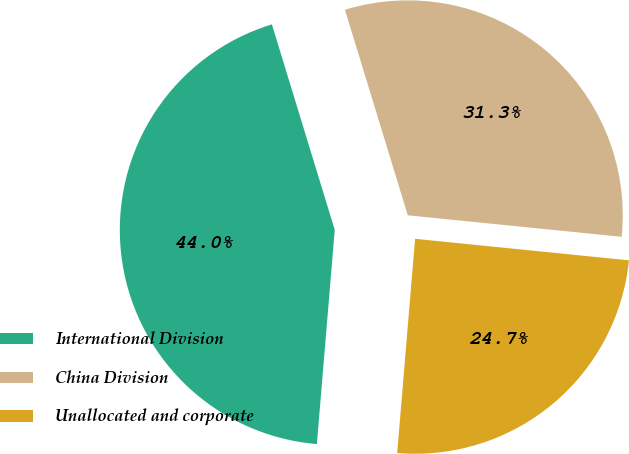Convert chart. <chart><loc_0><loc_0><loc_500><loc_500><pie_chart><fcel>International Division<fcel>China Division<fcel>Unallocated and corporate<nl><fcel>43.95%<fcel>31.32%<fcel>24.73%<nl></chart> 